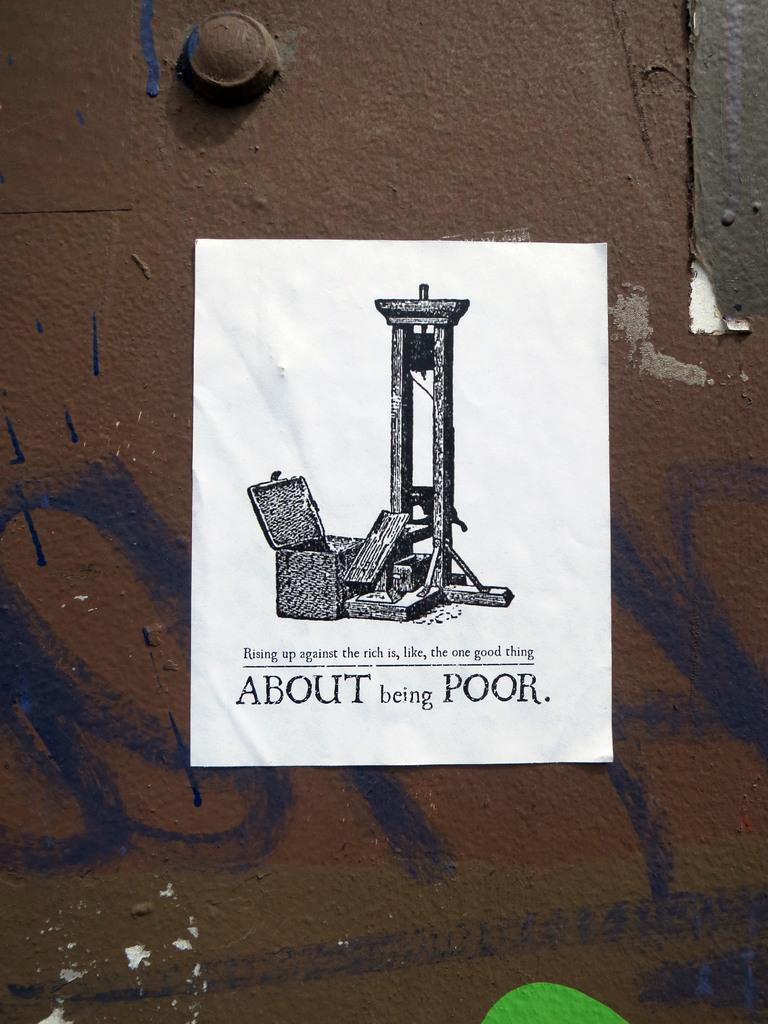Provide a one-sentence caption for the provided image. A flyer with a guillotine on it that says About being Poor at the bottom. 